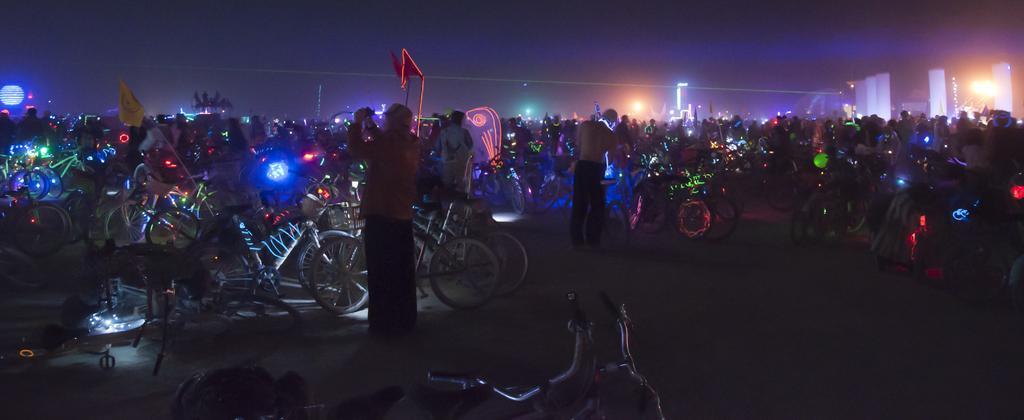Describe this image in one or two sentences. In the center of the image there are many people and bicycles. This image is taken at the nighttime. There is a flag in the image 